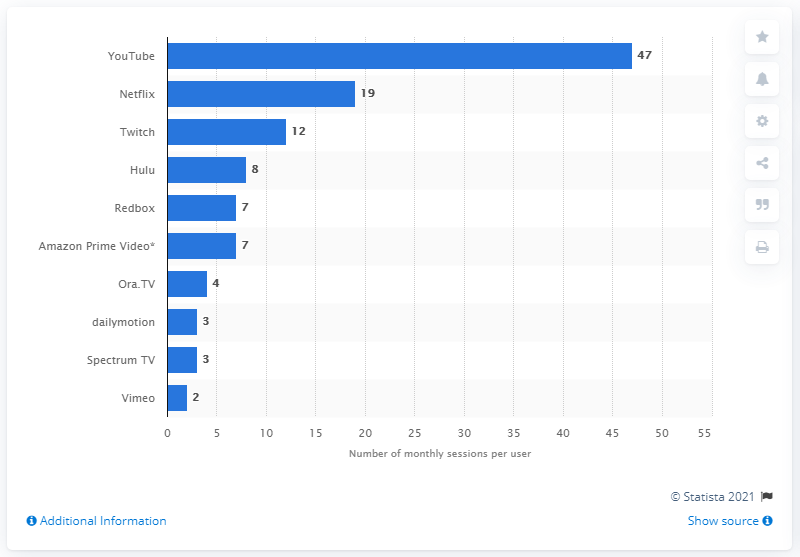Mention a couple of crucial points in this snapshot. YouTube was the most popular video streaming service as of July 2018. Netflix had an average of 19 monthly sessions per user in a given month. 